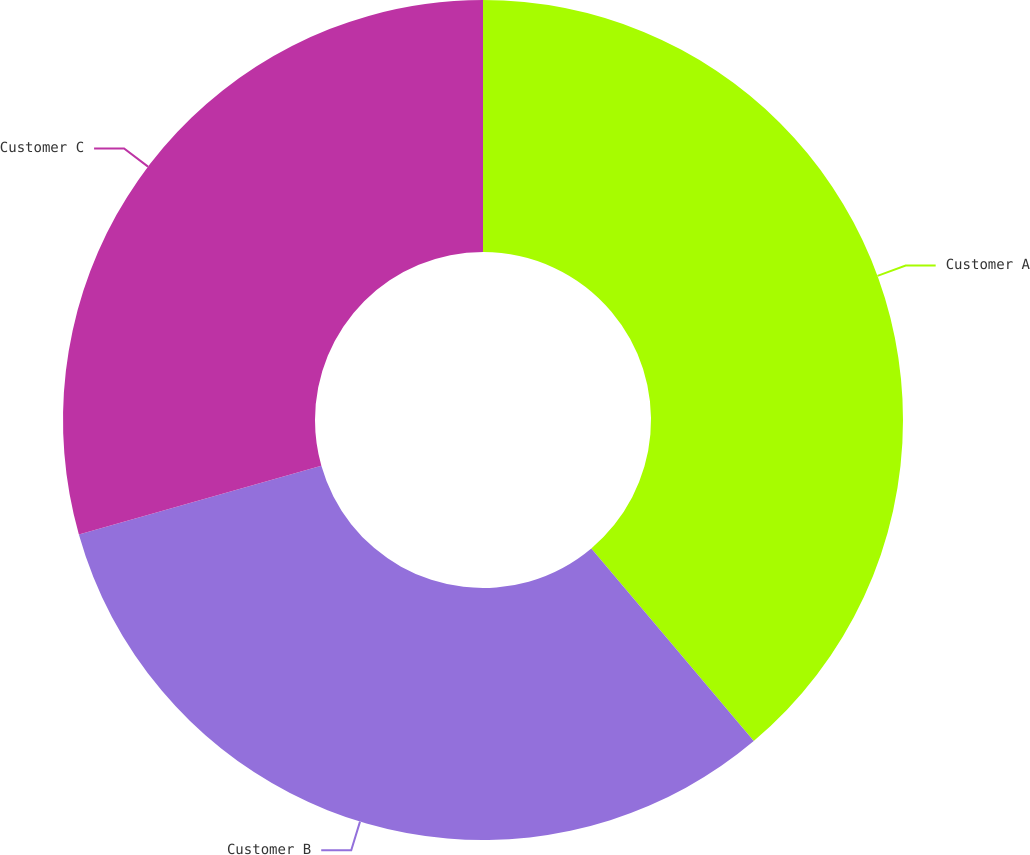<chart> <loc_0><loc_0><loc_500><loc_500><pie_chart><fcel>Customer A<fcel>Customer B<fcel>Customer C<nl><fcel>38.85%<fcel>31.76%<fcel>29.39%<nl></chart> 